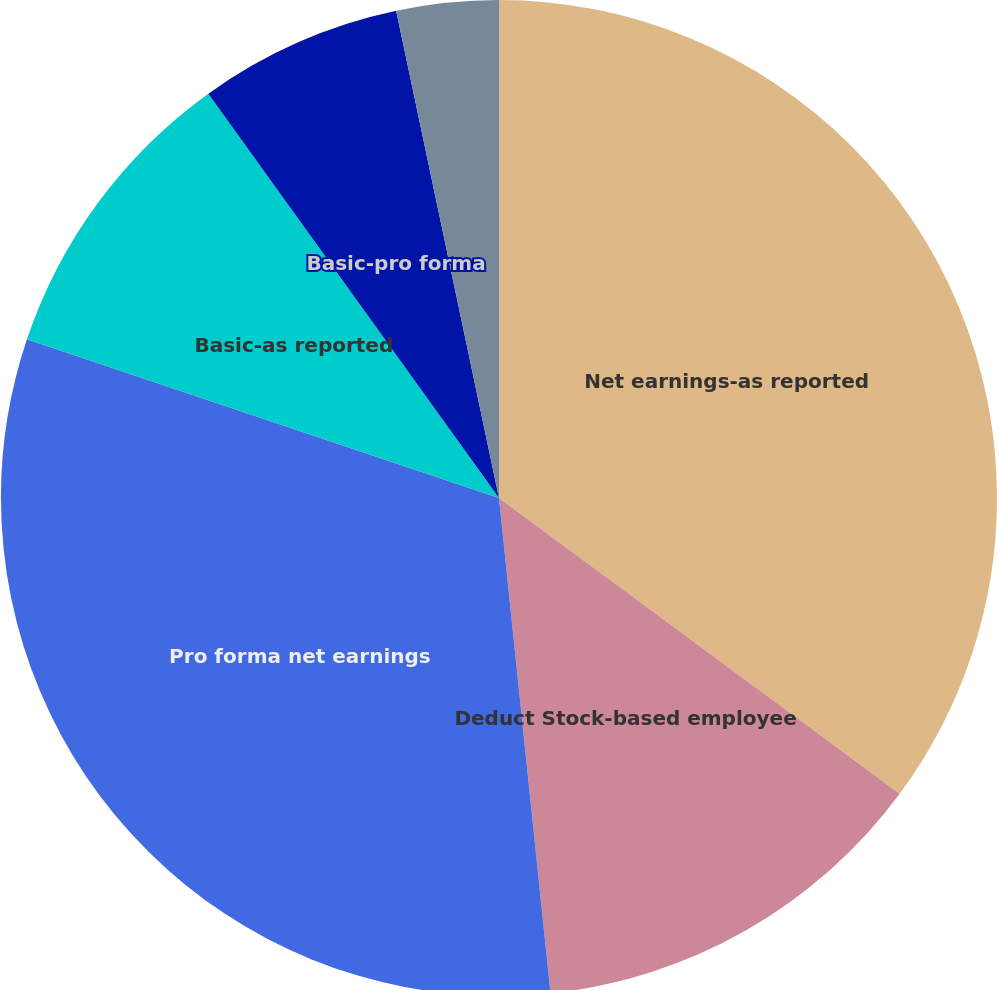Convert chart. <chart><loc_0><loc_0><loc_500><loc_500><pie_chart><fcel>Net earnings-as reported<fcel>Deduct Stock-based employee<fcel>Pro forma net earnings<fcel>Basic-as reported<fcel>Basic-pro forma<fcel>Diluted-as reported<fcel>Diluted-pro forma<nl><fcel>35.12%<fcel>13.23%<fcel>31.81%<fcel>9.92%<fcel>6.61%<fcel>3.31%<fcel>0.0%<nl></chart> 